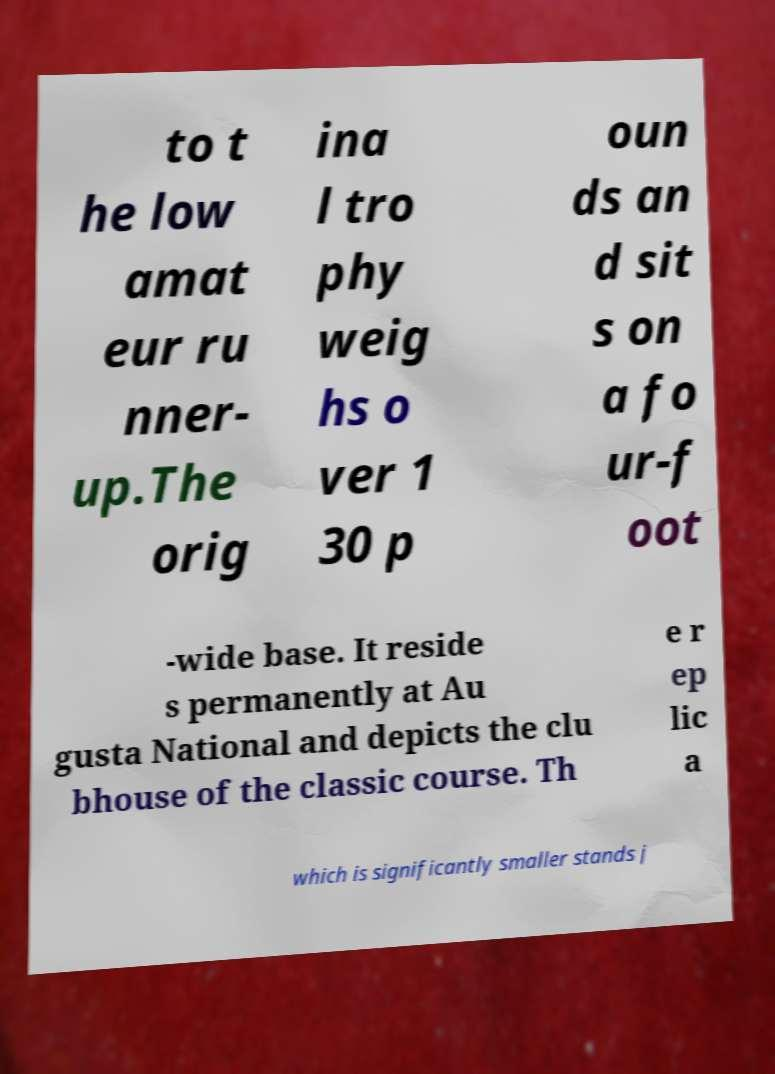Could you extract and type out the text from this image? to t he low amat eur ru nner- up.The orig ina l tro phy weig hs o ver 1 30 p oun ds an d sit s on a fo ur-f oot -wide base. It reside s permanently at Au gusta National and depicts the clu bhouse of the classic course. Th e r ep lic a which is significantly smaller stands j 